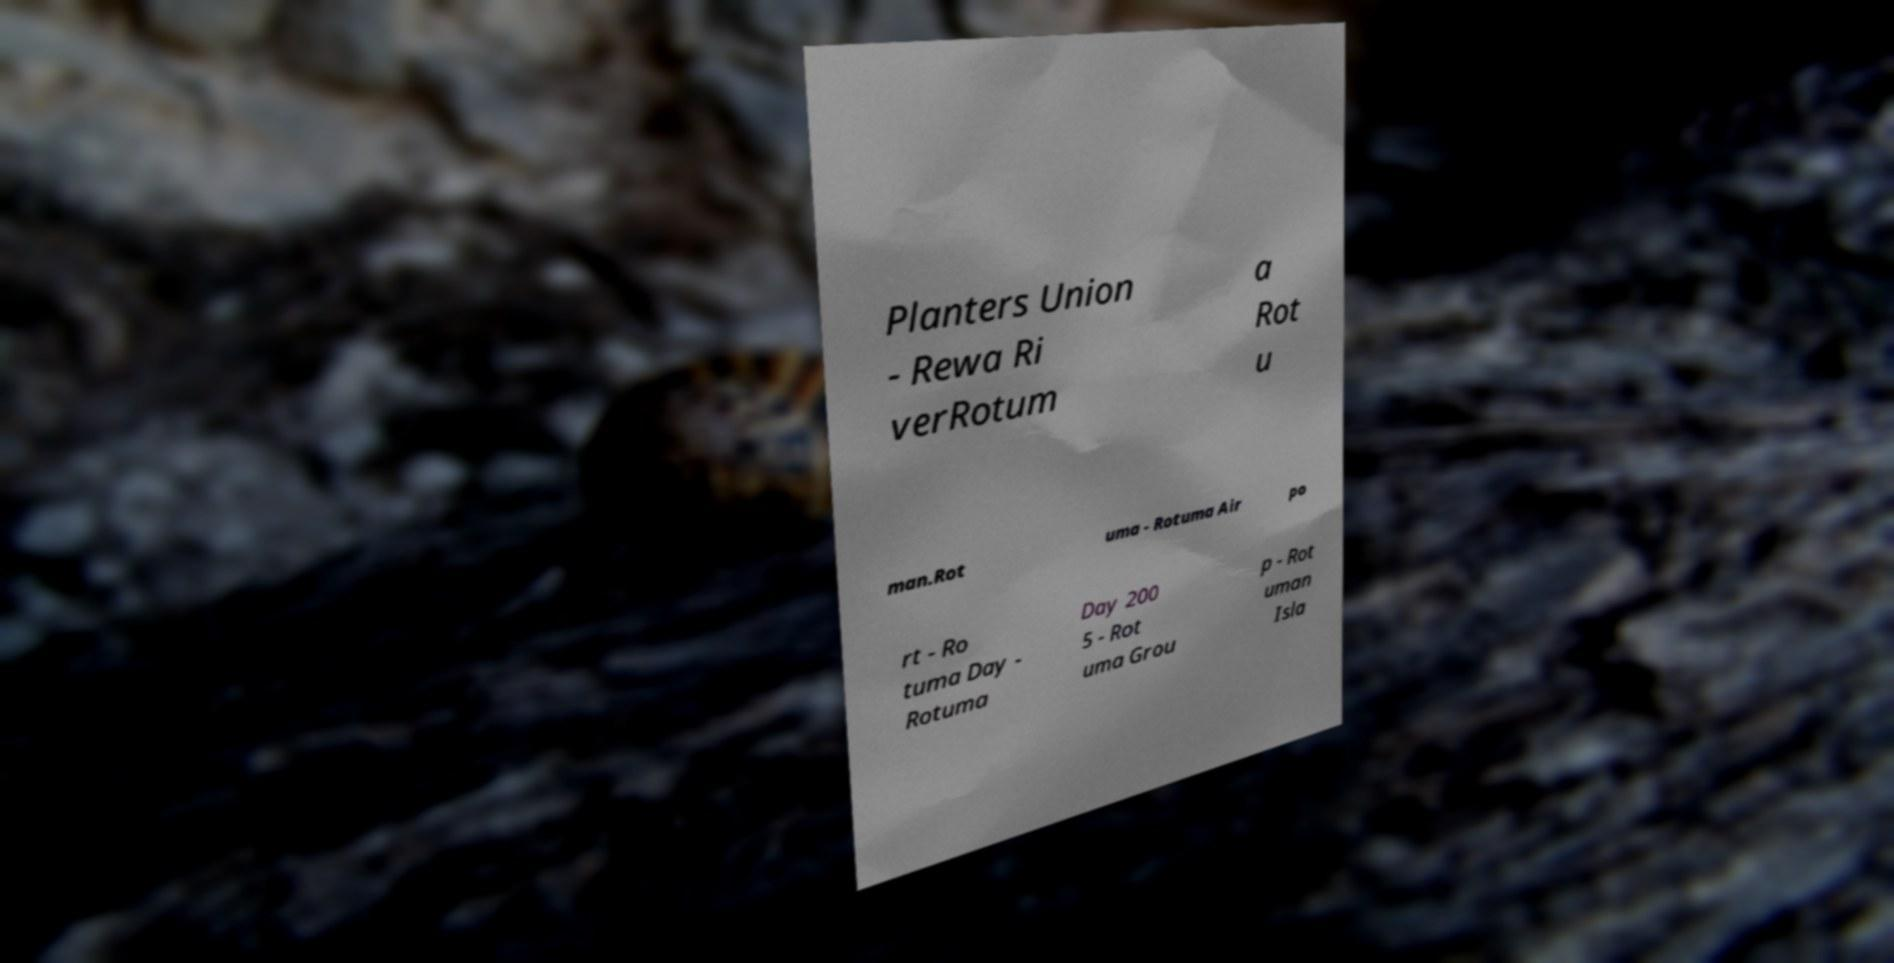Can you read and provide the text displayed in the image?This photo seems to have some interesting text. Can you extract and type it out for me? Planters Union - Rewa Ri verRotum a Rot u man.Rot uma - Rotuma Air po rt - Ro tuma Day - Rotuma Day 200 5 - Rot uma Grou p - Rot uman Isla 